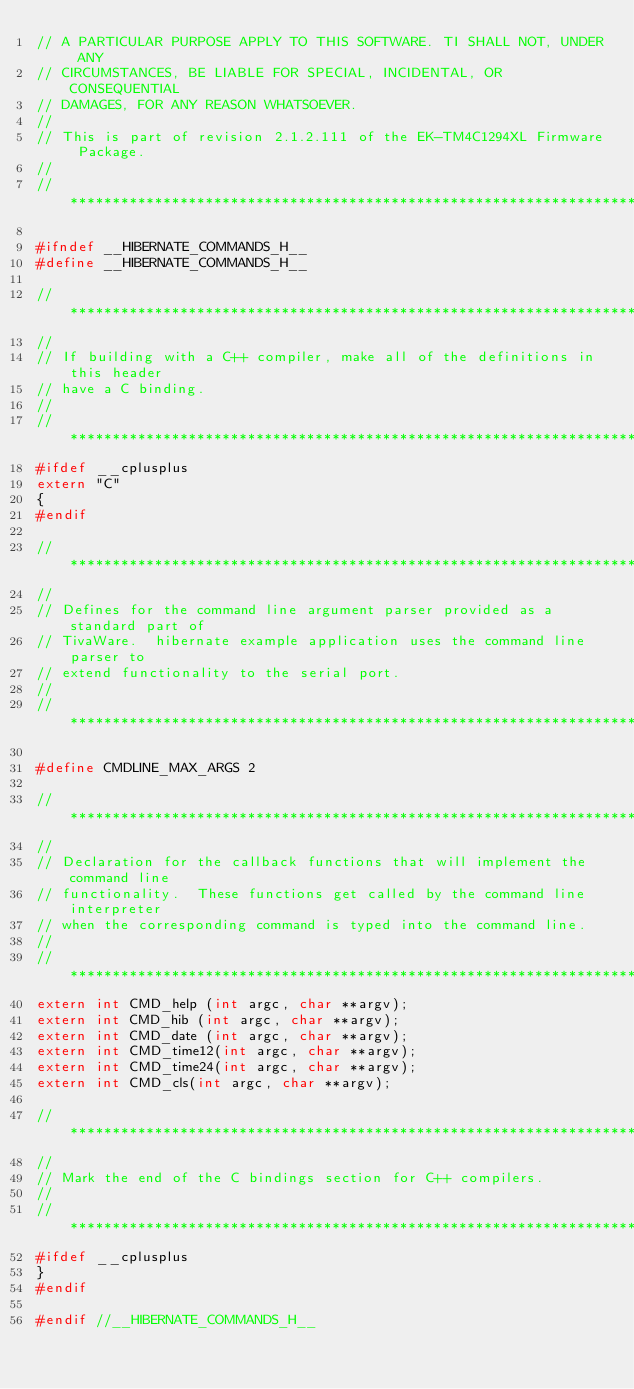<code> <loc_0><loc_0><loc_500><loc_500><_C_>// A PARTICULAR PURPOSE APPLY TO THIS SOFTWARE. TI SHALL NOT, UNDER ANY
// CIRCUMSTANCES, BE LIABLE FOR SPECIAL, INCIDENTAL, OR CONSEQUENTIAL
// DAMAGES, FOR ANY REASON WHATSOEVER.
// 
// This is part of revision 2.1.2.111 of the EK-TM4C1294XL Firmware Package.
//
//*****************************************************************************

#ifndef __HIBERNATE_COMMANDS_H__
#define __HIBERNATE_COMMANDS_H__

//*****************************************************************************
//
// If building with a C++ compiler, make all of the definitions in this header
// have a C binding.
//
//*****************************************************************************
#ifdef __cplusplus
extern "C"
{
#endif

//*****************************************************************************
//
// Defines for the command line argument parser provided as a standard part of
// TivaWare.  hibernate example application uses the command line parser to
// extend functionality to the serial port.
//
//*****************************************************************************

#define CMDLINE_MAX_ARGS 2

//*****************************************************************************
//
// Declaration for the callback functions that will implement the command line
// functionality.  These functions get called by the command line interpreter
// when the corresponding command is typed into the command line.
//
//*****************************************************************************
extern int CMD_help (int argc, char **argv);
extern int CMD_hib (int argc, char **argv);
extern int CMD_date (int argc, char **argv);
extern int CMD_time12(int argc, char **argv);
extern int CMD_time24(int argc, char **argv);
extern int CMD_cls(int argc, char **argv);

//*****************************************************************************
//
// Mark the end of the C bindings section for C++ compilers.
//
//*****************************************************************************
#ifdef __cplusplus
}
#endif

#endif //__HIBERNATE_COMMANDS_H__
</code> 